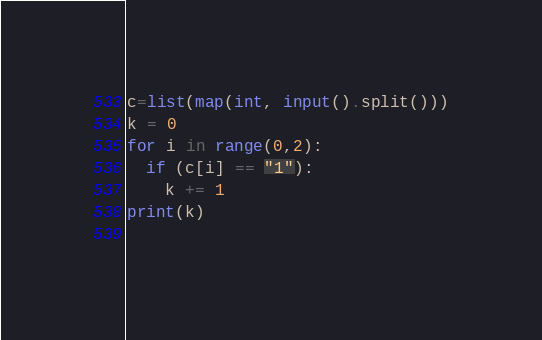<code> <loc_0><loc_0><loc_500><loc_500><_Python_>c=list(map(int, input().split()))
k = 0
for i in range(0,2):
  if (c[i] == "1"):
    k += 1
print(k)
  </code> 